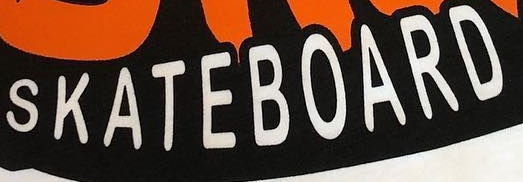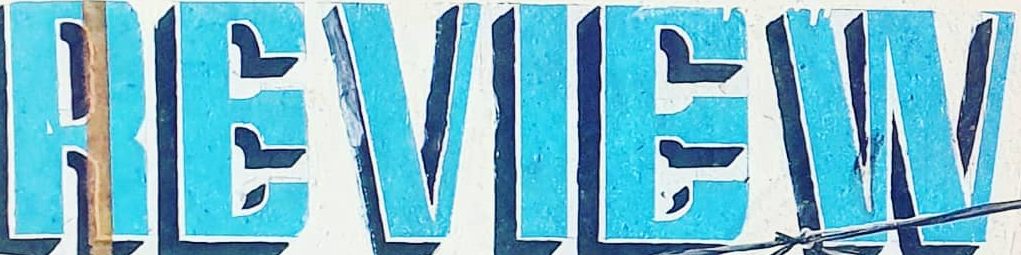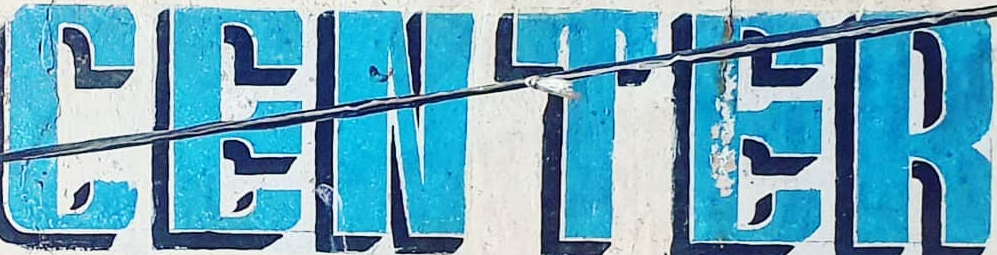What text appears in these images from left to right, separated by a semicolon? SKATEBOARD; REVIEW; CENTER 